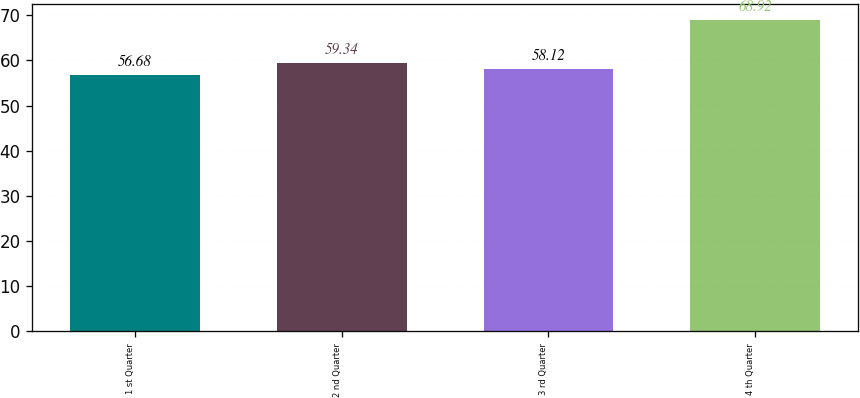Convert chart to OTSL. <chart><loc_0><loc_0><loc_500><loc_500><bar_chart><fcel>1 st Quarter<fcel>2 nd Quarter<fcel>3 rd Quarter<fcel>4 th Quarter<nl><fcel>56.68<fcel>59.34<fcel>58.12<fcel>68.92<nl></chart> 